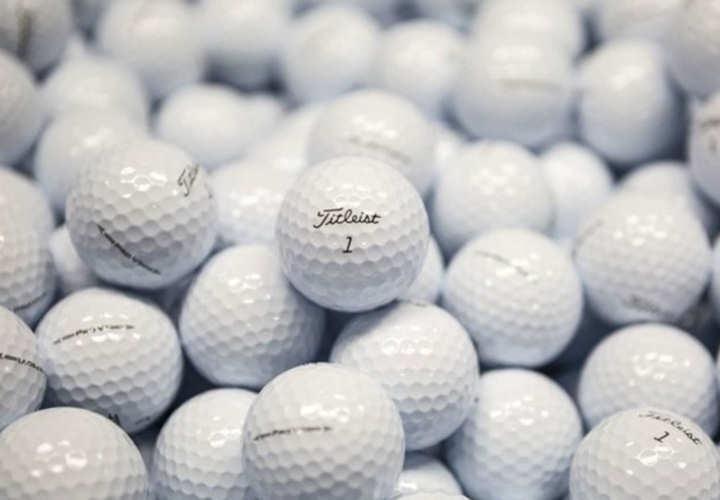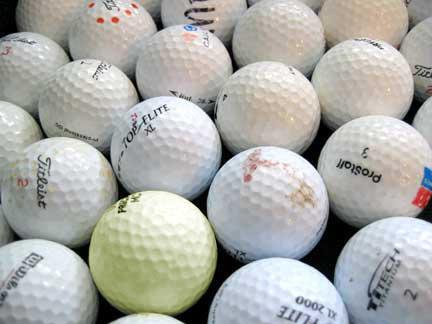The first image is the image on the left, the second image is the image on the right. Evaluate the accuracy of this statement regarding the images: "There are multiple golf balls in each image, and no visible containers.". Is it true? Answer yes or no. Yes. The first image is the image on the left, the second image is the image on the right. Assess this claim about the two images: "At least one image shows only white golf balls with no logo or name markings". Correct or not? Answer yes or no. No. 